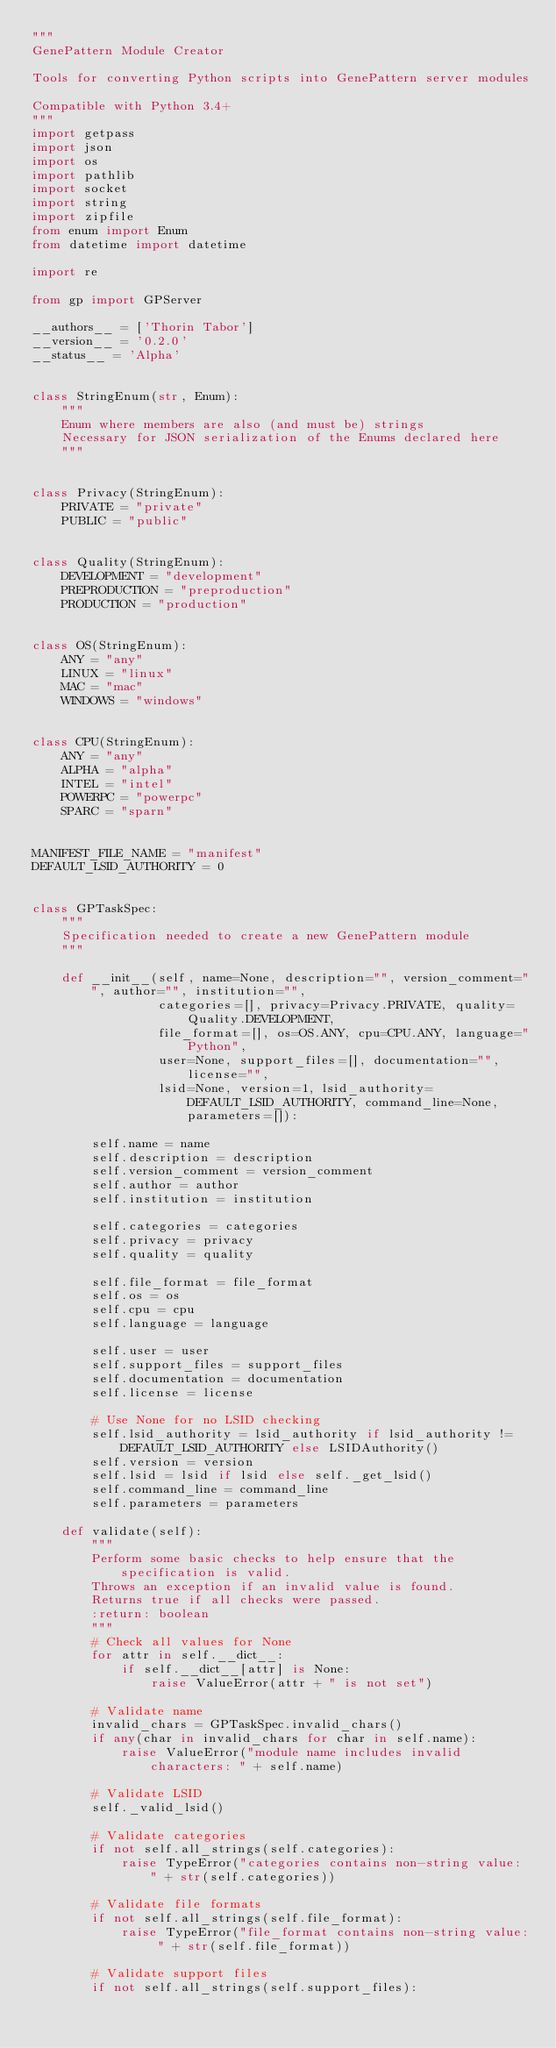<code> <loc_0><loc_0><loc_500><loc_500><_Python_>"""
GenePattern Module Creator

Tools for converting Python scripts into GenePattern server modules

Compatible with Python 3.4+
"""
import getpass
import json
import os
import pathlib
import socket
import string
import zipfile
from enum import Enum
from datetime import datetime

import re

from gp import GPServer

__authors__ = ['Thorin Tabor']
__version__ = '0.2.0'
__status__ = 'Alpha'


class StringEnum(str, Enum):
    """
    Enum where members are also (and must be) strings
    Necessary for JSON serialization of the Enums declared here
    """


class Privacy(StringEnum):
    PRIVATE = "private"
    PUBLIC = "public"


class Quality(StringEnum):
    DEVELOPMENT = "development"
    PREPRODUCTION = "preproduction"
    PRODUCTION = "production"


class OS(StringEnum):
    ANY = "any"
    LINUX = "linux"
    MAC = "mac"
    WINDOWS = "windows"


class CPU(StringEnum):
    ANY = "any"
    ALPHA = "alpha"
    INTEL = "intel"
    POWERPC = "powerpc"
    SPARC = "sparn"


MANIFEST_FILE_NAME = "manifest"
DEFAULT_LSID_AUTHORITY = 0


class GPTaskSpec:
    """
    Specification needed to create a new GenePattern module
    """

    def __init__(self, name=None, description="", version_comment="", author="", institution="",
                 categories=[], privacy=Privacy.PRIVATE, quality=Quality.DEVELOPMENT,
                 file_format=[], os=OS.ANY, cpu=CPU.ANY, language="Python",
                 user=None, support_files=[], documentation="", license="",
                 lsid=None, version=1, lsid_authority=DEFAULT_LSID_AUTHORITY, command_line=None, parameters=[]):

        self.name = name
        self.description = description
        self.version_comment = version_comment
        self.author = author
        self.institution = institution

        self.categories = categories
        self.privacy = privacy
        self.quality = quality

        self.file_format = file_format
        self.os = os
        self.cpu = cpu
        self.language = language

        self.user = user
        self.support_files = support_files
        self.documentation = documentation
        self.license = license

        # Use None for no LSID checking
        self.lsid_authority = lsid_authority if lsid_authority != DEFAULT_LSID_AUTHORITY else LSIDAuthority()
        self.version = version
        self.lsid = lsid if lsid else self._get_lsid()
        self.command_line = command_line
        self.parameters = parameters

    def validate(self):
        """
        Perform some basic checks to help ensure that the specification is valid.
        Throws an exception if an invalid value is found.
        Returns true if all checks were passed.
        :return: boolean
        """
        # Check all values for None
        for attr in self.__dict__:
            if self.__dict__[attr] is None:
                raise ValueError(attr + " is not set")

        # Validate name
        invalid_chars = GPTaskSpec.invalid_chars()
        if any(char in invalid_chars for char in self.name):
            raise ValueError("module name includes invalid characters: " + self.name)

        # Validate LSID
        self._valid_lsid()

        # Validate categories
        if not self.all_strings(self.categories):
            raise TypeError("categories contains non-string value: " + str(self.categories))

        # Validate file formats
        if not self.all_strings(self.file_format):
            raise TypeError("file_format contains non-string value: " + str(self.file_format))

        # Validate support files
        if not self.all_strings(self.support_files):</code> 